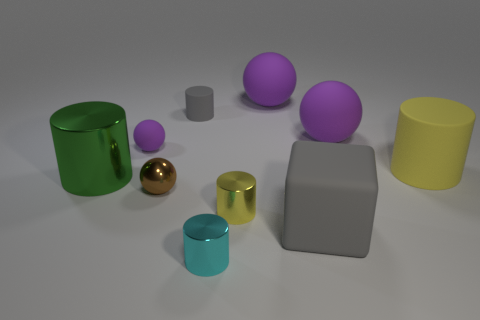Can you tell me about the colors of the objects in the image? Certainly! The image showcases objects with a vibrant array of colors. There are objects in shades of purple, green, blue, yellow, and gold. The use of color could be interpreted as a study in color theory, with both primary and secondary colors represented, which creates a visually engaging and playful composition. Which color appears most frequently? Purple seems to be the most prevalent color, featuring in both a larger spherical object as well as a smaller one. The repetition of this hue can create a sense of balance and rhythm within the composition. 